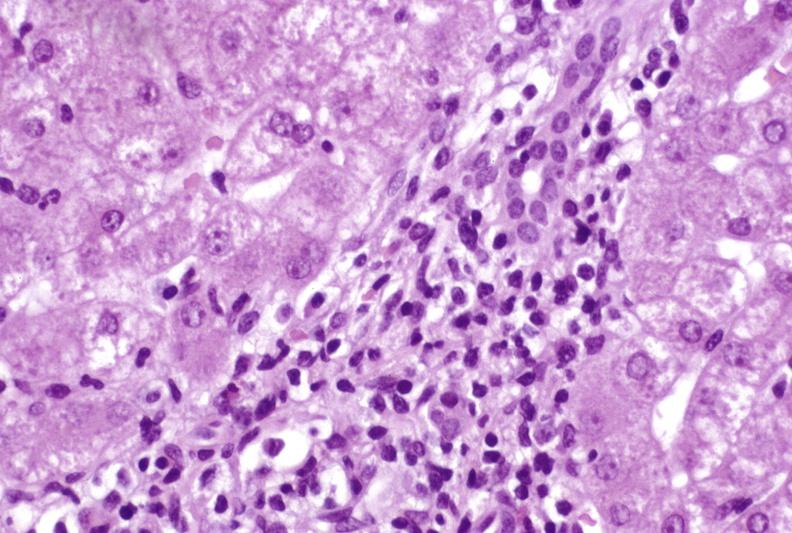what is present?
Answer the question using a single word or phrase. Hepatobiliary 